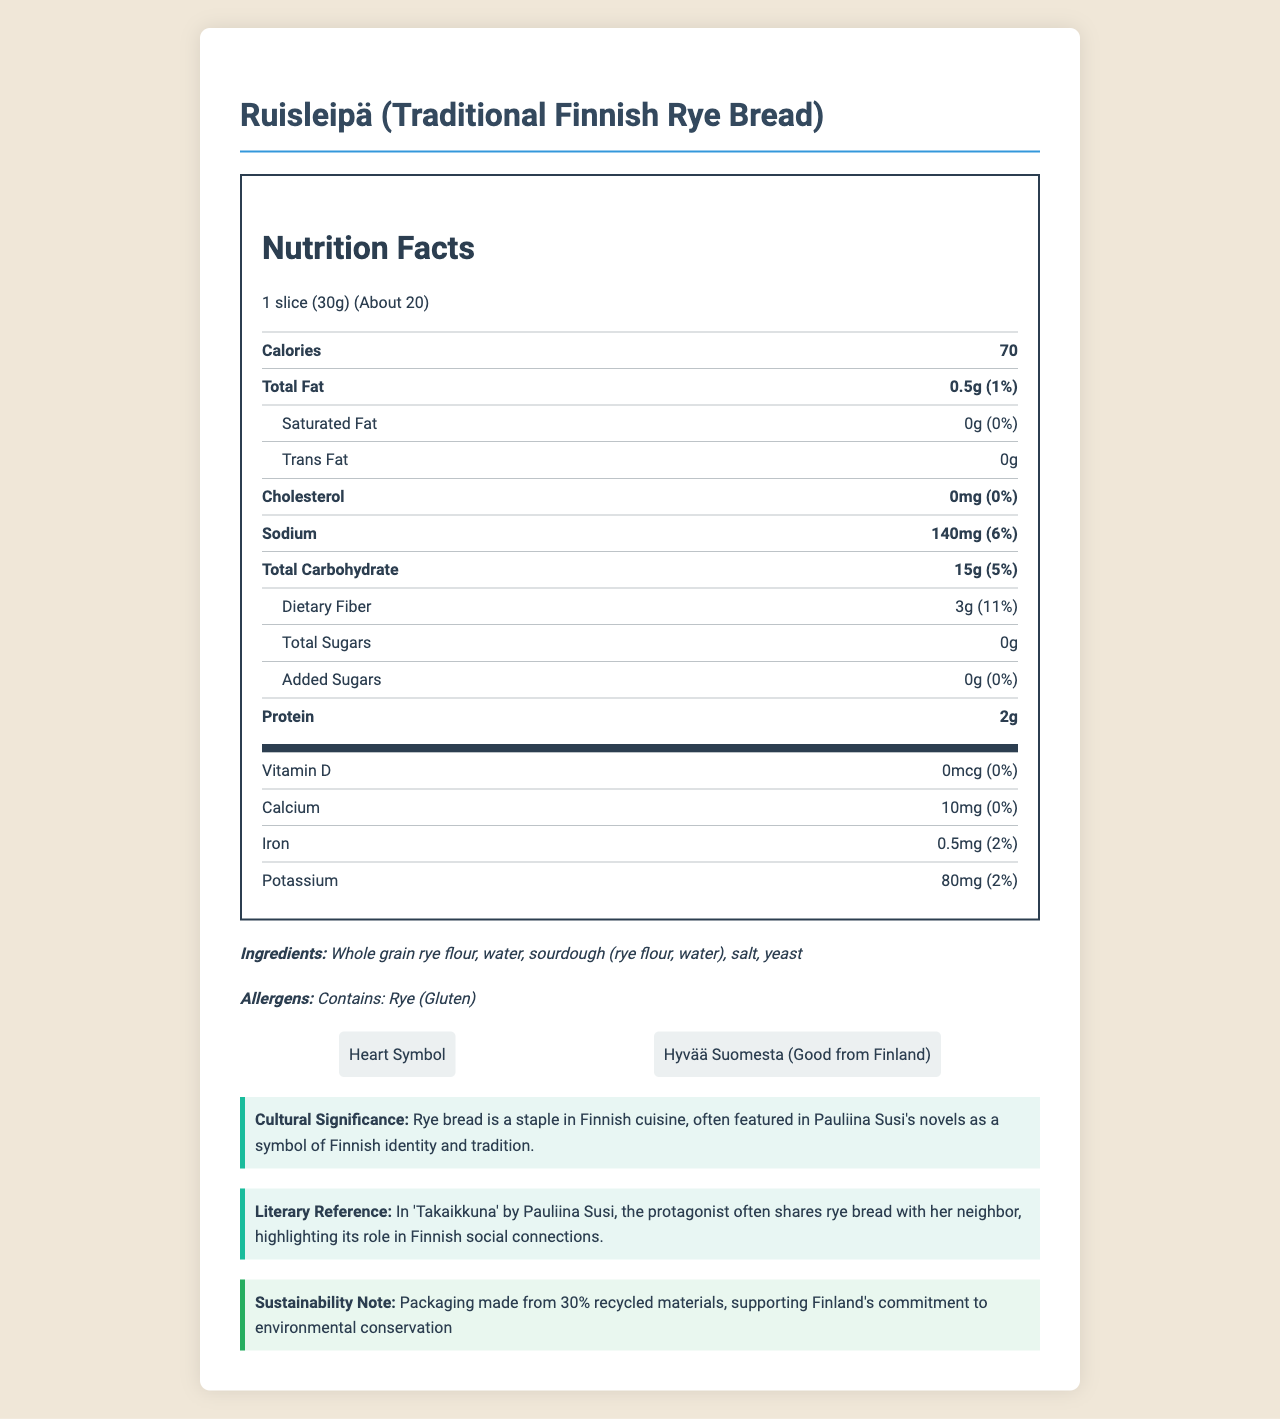what is the serving size for Ruisleipä? The serving size is listed as "1 slice (30g)" in the serving size section.
Answer: 1 slice (30g) how many calories are in one serving? The calories per serving are listed as 70 in the nutrition label.
Answer: 70 calories what is the amount of dietary fiber per serving? The dietary fiber amount is listed as 3g in the nutrition label.
Answer: 3g identify two key certifications for Ruisleipä. The certifications listed are "Heart Symbol" and "Hyvää Suomesta (Good from Finland)" in the certifications section.
Answer: Heart Symbol, Hyvää Suomesta (Good from Finland) what is the total fat content per serving? The total fat amount is listed as "0.5g" in the nutrition label.
Answer: 0.5g where is the manufacturer located? The manufacturer location is listed as "Helsinki, Finland" in the document.
Answer: Helsinki, Finland does the product contain any added sugars? The total and added sugars listed are both "0g", indicating no added sugars.
Answer: No what is the primary ingredient in Ruisleipä? The first ingredient listed is "Whole grain rye flour," indicating it is the primary ingredient.
Answer: Whole grain rye flour how much sodium is in one serving? The sodium amount is listed as 140mg in the nutrition label.
Answer: 140mg who is the brand name for Ruisleipä? The brand name is "Fazer Ruisleipä" as mentioned in the document.
Answer: Fazer Ruisleipä what does the Heart Symbol certification signify? The document lists the certification but does not explain what it signifies.
Answer: The document does not provide specific details on the Heart Symbol certification. which of the following nutrients has the highest daily value percentage per serving? A. Dietary Fiber B. Sodium C. Iron Dietary fiber has an 11% daily value, sodium has 6%, and iron has 2%.
Answer: A. Dietary Fiber which option illustrates the cultural significance of rye bread in Finnish cuisine? A. It is a staple food often eaten during meals. B. It represents Finnish identity and tradition in literature. C. It is used primarily as a dessert ingredient. Rye bread is described as a staple in Finnish cuisine and a symbol of Finnish identity and tradition in literature.
Answer: B. It represents Finnish identity and tradition in literature. is Ruisleipä high in fiber? The nutrition highlights specifically mention it is high in fiber with 3g per slice.
Answer: Yes summarize the main nutrition-related highlights of Ruisleipä. The nutrition highlights section details these main points, underscoring its high fiber content, lack of added sugars, low fat, and provision of complex carbohydrates.
Answer: Ruisleipä is high in fiber, low in fat, contains no added sugars, and provides complex carbohydrates for sustained energy. what is the environmental sustainability feature of the packaging? The sustainability note indicates the packaging uses 30% recycled materials, supporting environmental conservation.
Answer: Packaging made from 30% recycled materials is there information about vitamin C content? The document does not provide any details about vitamin C content.
Answer: No explain the role of rye bread in 'Takaikkuna' by Pauliina Susi. This information is found in the literary reference section, demonstrating rye bread's cultural and social importance in Finnish literature.
Answer: In 'Takaikkuna', the protagonist often shares rye bread with her neighbor, highlighting its role in Finnish social connections. 